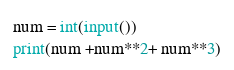Convert code to text. <code><loc_0><loc_0><loc_500><loc_500><_Python_>num = int(input())
print(num +num**2+ num**3)</code> 